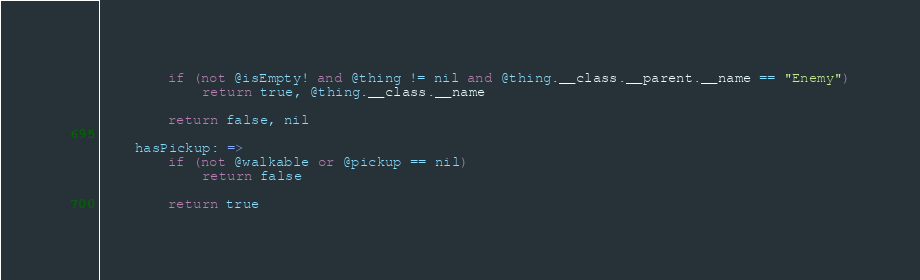<code> <loc_0><loc_0><loc_500><loc_500><_MoonScript_>

        if (not @isEmpty! and @thing != nil and @thing.__class.__parent.__name == "Enemy")
            return true, @thing.__class.__name

        return false, nil

    hasPickup: =>
        if (not @walkable or @pickup == nil)
            return false

        return true
</code> 